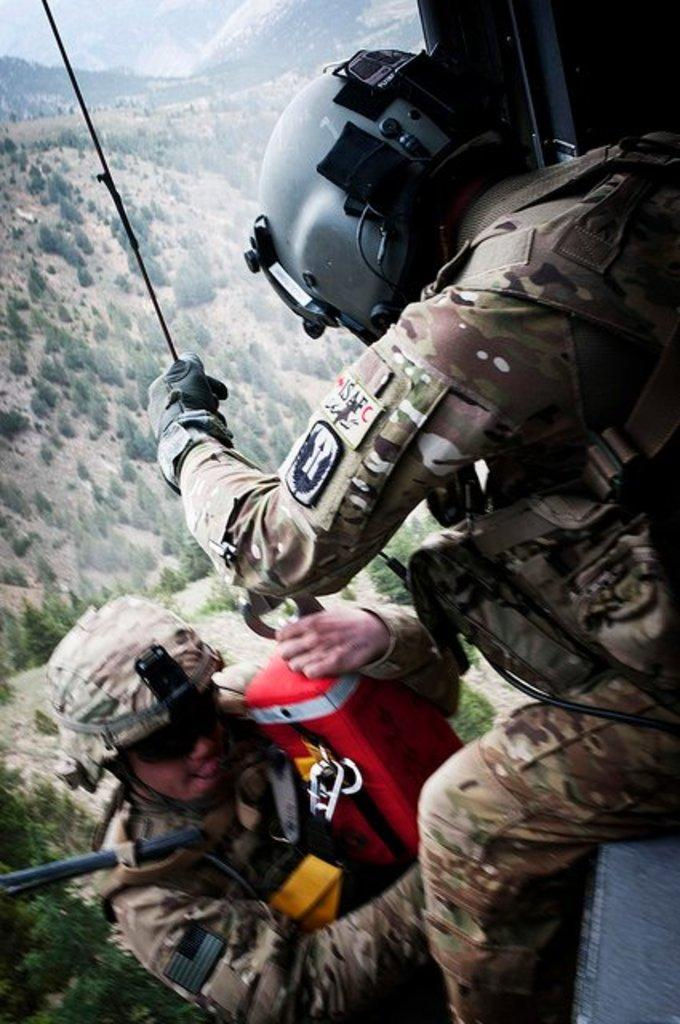What is happening in the foreground of the image? There are persons jumping from the aircraft in the foreground. What can be seen in the background of the image? There are trees and mountains in the background. How much profit can be made from the sink in the image? There is no sink present in the image, so it is not possible to determine any profit related to it. 